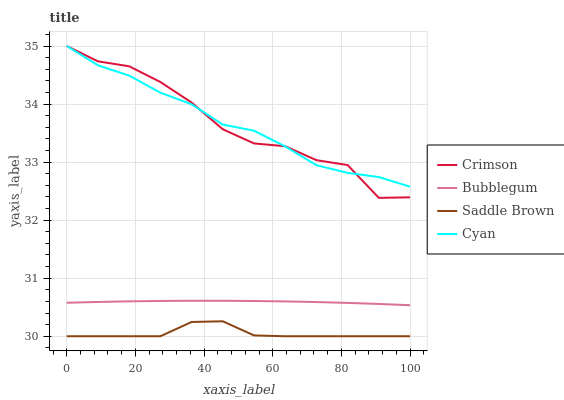Does Cyan have the minimum area under the curve?
Answer yes or no. No. Does Saddle Brown have the maximum area under the curve?
Answer yes or no. No. Is Cyan the smoothest?
Answer yes or no. No. Is Cyan the roughest?
Answer yes or no. No. Does Cyan have the lowest value?
Answer yes or no. No. Does Saddle Brown have the highest value?
Answer yes or no. No. Is Bubblegum less than Crimson?
Answer yes or no. Yes. Is Crimson greater than Saddle Brown?
Answer yes or no. Yes. Does Bubblegum intersect Crimson?
Answer yes or no. No. 